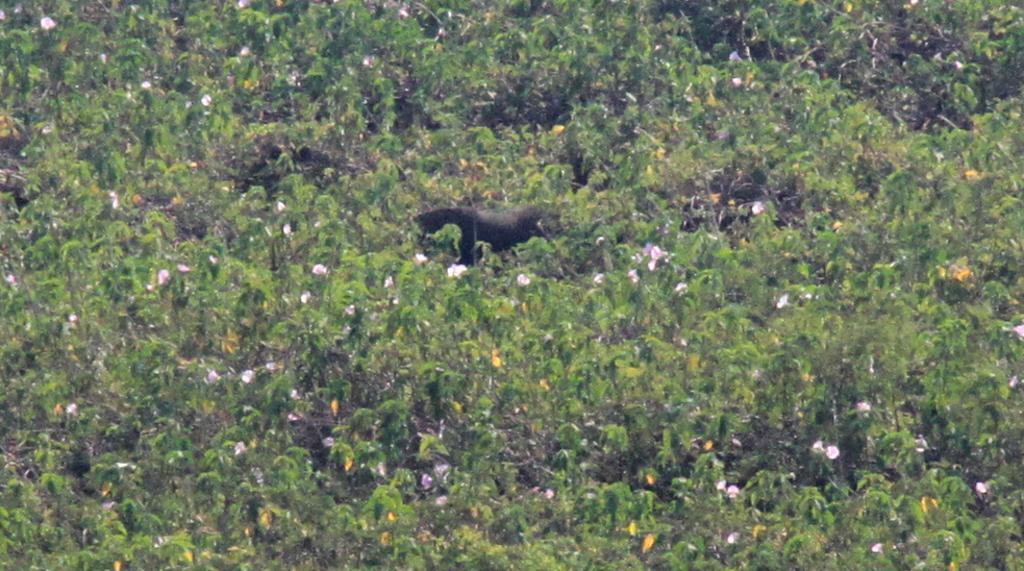Where was the image taken? The image was taken outdoors. What can be seen growing in the image? There are many plants with flowers in the image. What color are the leaves of the plants? The plants have green leaves. What is located in the middle of the image? There is a scarecrow in the middle of the image. What type of organization is the scarecrow affiliated with in the image? The image does not provide any information about the scarecrow's affiliations or any organizations. How many legs does the scarecrow have in the image? The scarecrow is not a living being and does not have legs in the image. 